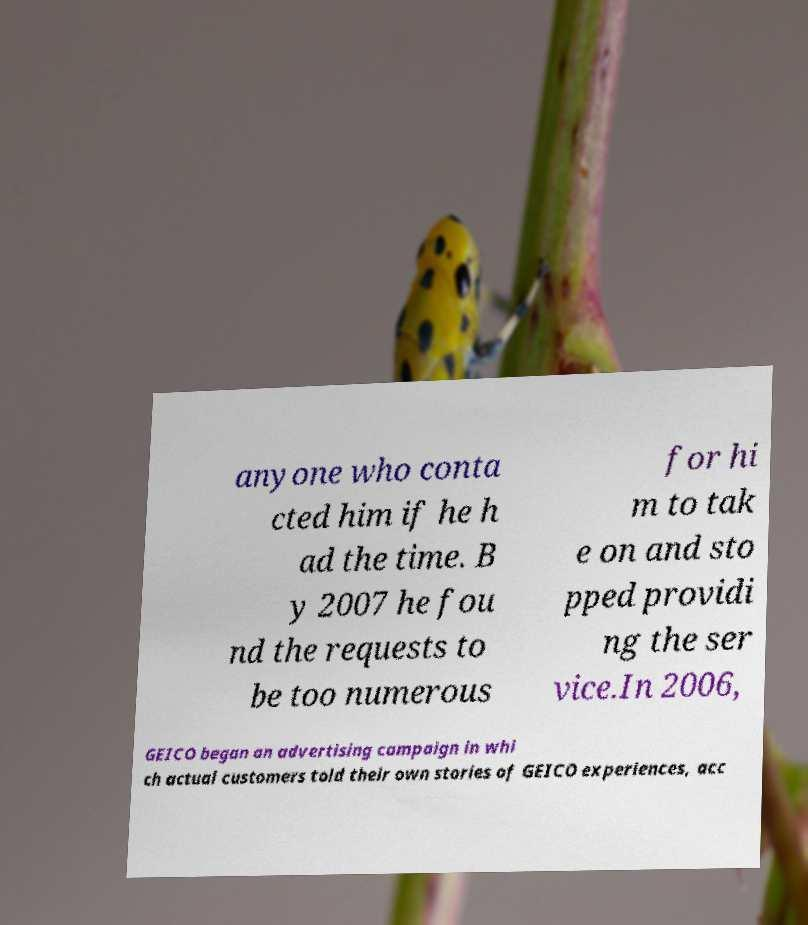What messages or text are displayed in this image? I need them in a readable, typed format. anyone who conta cted him if he h ad the time. B y 2007 he fou nd the requests to be too numerous for hi m to tak e on and sto pped providi ng the ser vice.In 2006, GEICO began an advertising campaign in whi ch actual customers told their own stories of GEICO experiences, acc 